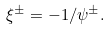Convert formula to latex. <formula><loc_0><loc_0><loc_500><loc_500>\xi ^ { \pm } = - 1 / \psi ^ { \pm } .</formula> 